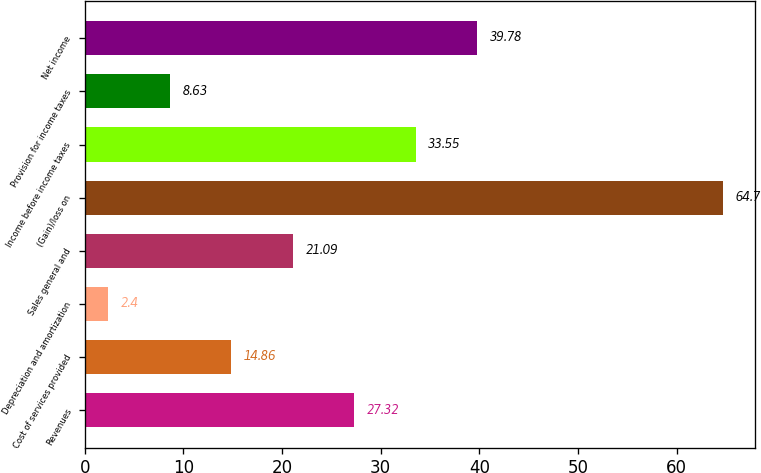<chart> <loc_0><loc_0><loc_500><loc_500><bar_chart><fcel>Revenues<fcel>Cost of services provided<fcel>Depreciation and amortization<fcel>Sales general and<fcel>(Gain)/loss on<fcel>Income before income taxes<fcel>Provision for income taxes<fcel>Net income<nl><fcel>27.32<fcel>14.86<fcel>2.4<fcel>21.09<fcel>64.7<fcel>33.55<fcel>8.63<fcel>39.78<nl></chart> 